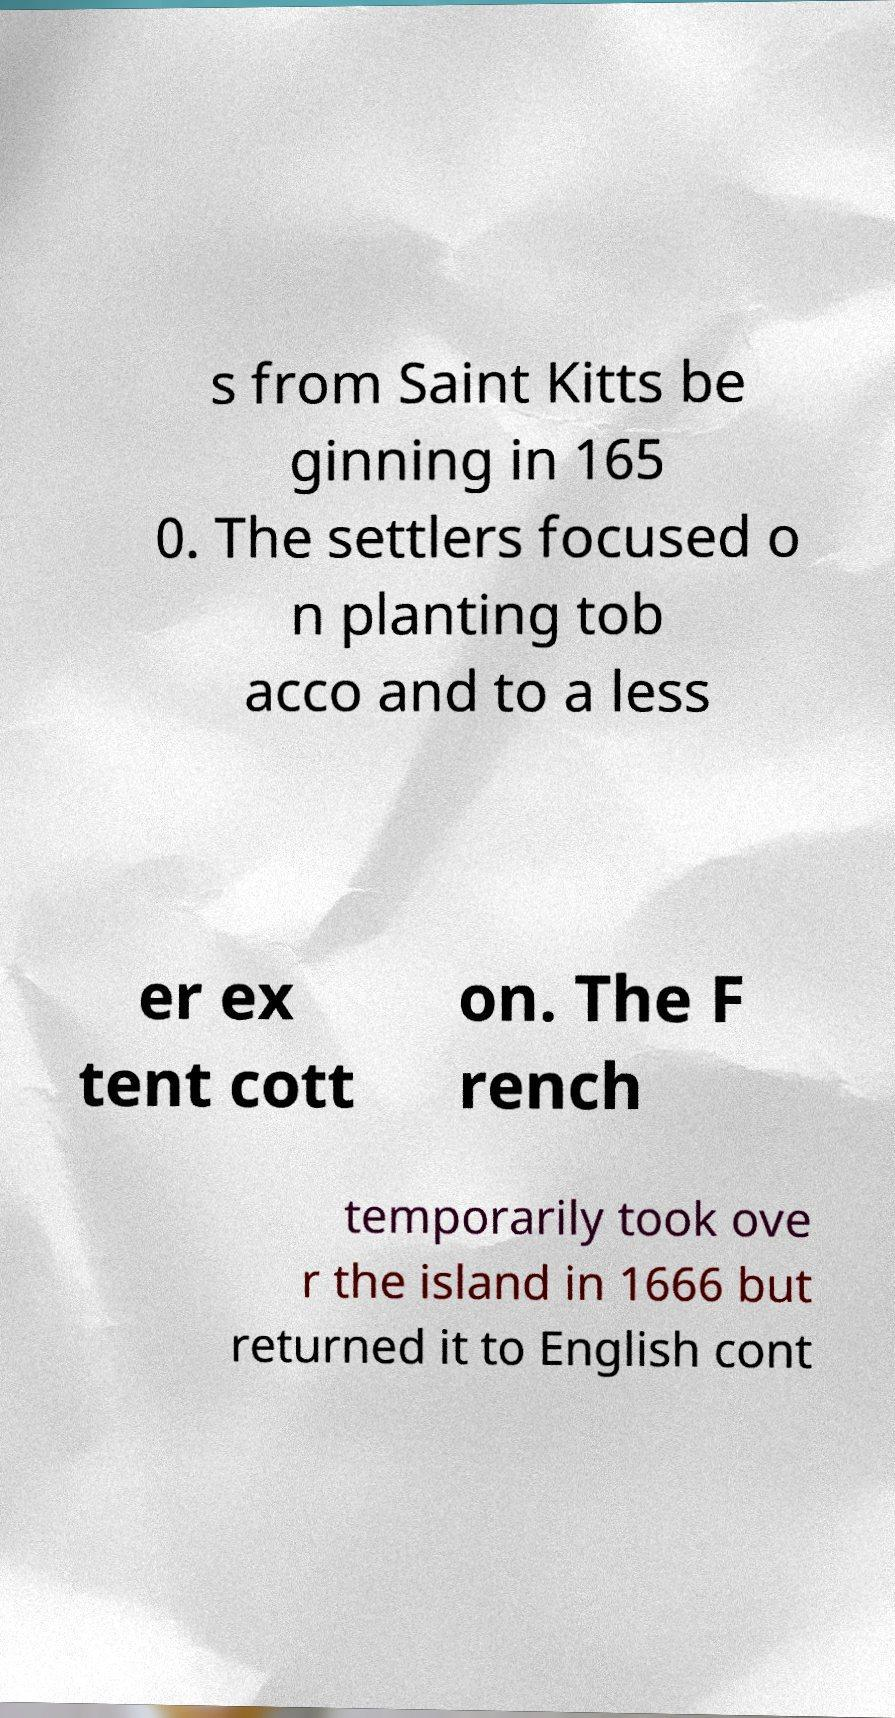Please identify and transcribe the text found in this image. s from Saint Kitts be ginning in 165 0. The settlers focused o n planting tob acco and to a less er ex tent cott on. The F rench temporarily took ove r the island in 1666 but returned it to English cont 